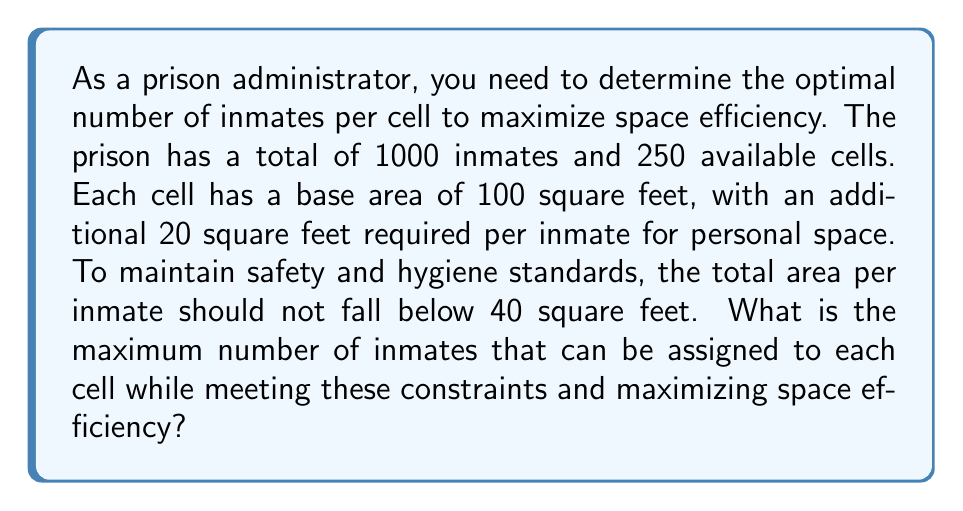Give your solution to this math problem. Let's approach this step-by-step:

1) Let $x$ be the number of inmates per cell.

2) The total area of a cell with $x$ inmates is:
   $$ A(x) = 100 + 20x $$

3) The area per inmate in a cell with $x$ inmates is:
   $$ A_i(x) = \frac{A(x)}{x} = \frac{100 + 20x}{x} $$

4) We need this area to be at least 40 square feet:
   $$ \frac{100 + 20x}{x} \geq 40 $$

5) Solving this inequality:
   $$ 100 + 20x \geq 40x $$
   $$ 100 \geq 20x $$
   $$ 5 \geq x $$

6) So, the maximum number of inmates per cell is 5.

7) Now, we need to check if this satisfies our total inmate constraint:
   $$ 250 \text{ cells} \times 5 \text{ inmates/cell} = 1250 \text{ inmates} $$

   This is more than our 1000 inmates, so 5 inmates per cell is feasible.

8) To maximize space efficiency, we want to use as few cells as possible. With 1000 inmates and a maximum of 5 per cell, we need:
   $$ \left\lceil\frac{1000 \text{ inmates}}{5 \text{ inmates/cell}}\right\rceil = 200 \text{ cells} $$

Therefore, to maximize space efficiency while meeting all constraints, we should assign 5 inmates to each of 200 cells.
Answer: 5 inmates per cell 